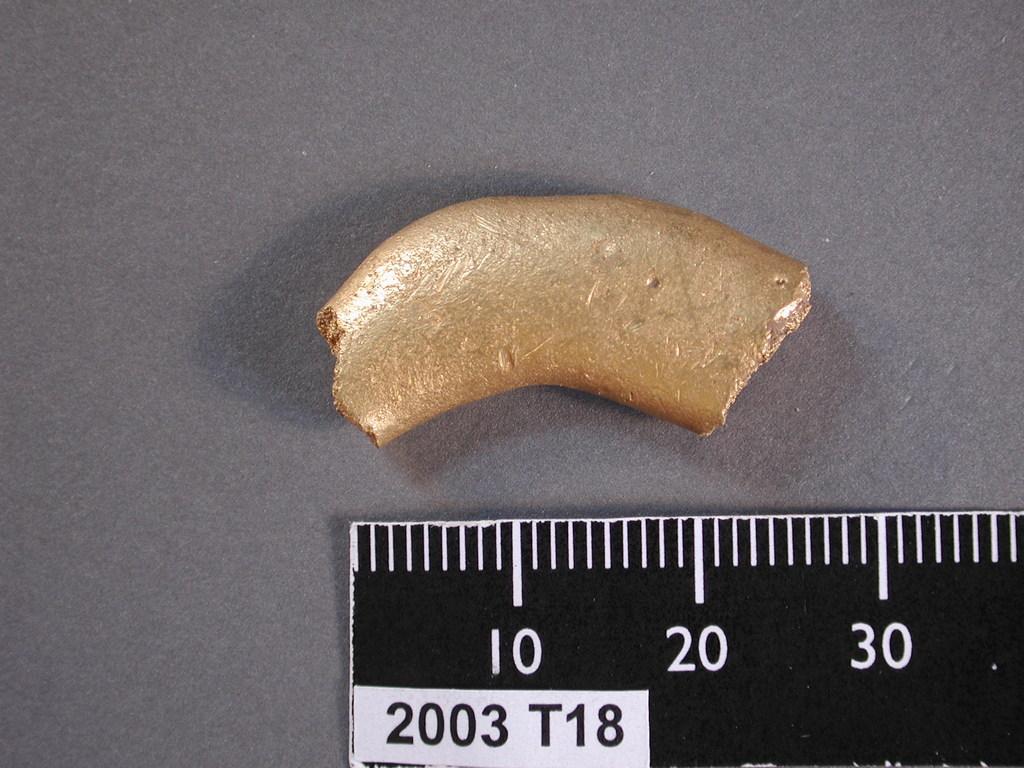How would you summarize this image in a sentence or two? In this image we can see a piece of metal and a scale placed on the surface. 